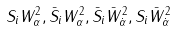Convert formula to latex. <formula><loc_0><loc_0><loc_500><loc_500>S _ { i } W _ { \alpha } ^ { 2 } , \bar { S } _ { i } W _ { \alpha } ^ { 2 } , \bar { S } _ { i } \bar { W } _ { \dot { \alpha } } ^ { 2 } , S _ { i } \bar { W } _ { \dot { \alpha } } ^ { 2 }</formula> 